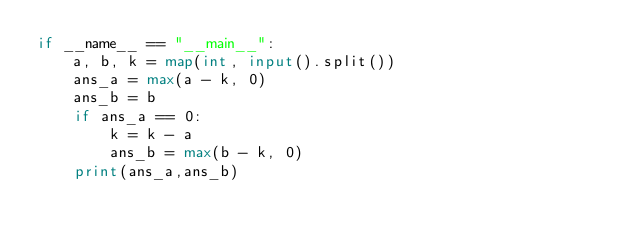Convert code to text. <code><loc_0><loc_0><loc_500><loc_500><_Python_>if __name__ == "__main__":
    a, b, k = map(int, input().split())
    ans_a = max(a - k, 0)
    ans_b = b
    if ans_a == 0:
        k = k - a
        ans_b = max(b - k, 0)           
    print(ans_a,ans_b)</code> 